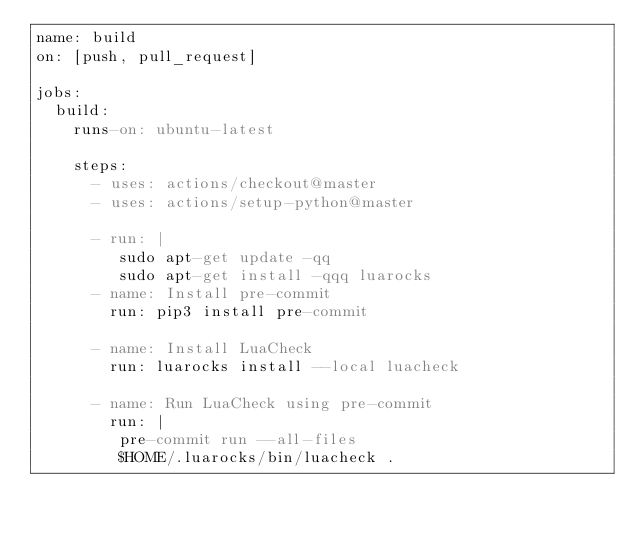<code> <loc_0><loc_0><loc_500><loc_500><_YAML_>name: build
on: [push, pull_request]

jobs:
  build:
    runs-on: ubuntu-latest

    steps:
      - uses: actions/checkout@master
      - uses: actions/setup-python@master

      - run: |
         sudo apt-get update -qq
         sudo apt-get install -qqq luarocks
      - name: Install pre-commit
        run: pip3 install pre-commit

      - name: Install LuaCheck
        run: luarocks install --local luacheck

      - name: Run LuaCheck using pre-commit
        run: |
         pre-commit run --all-files
         $HOME/.luarocks/bin/luacheck .
</code> 